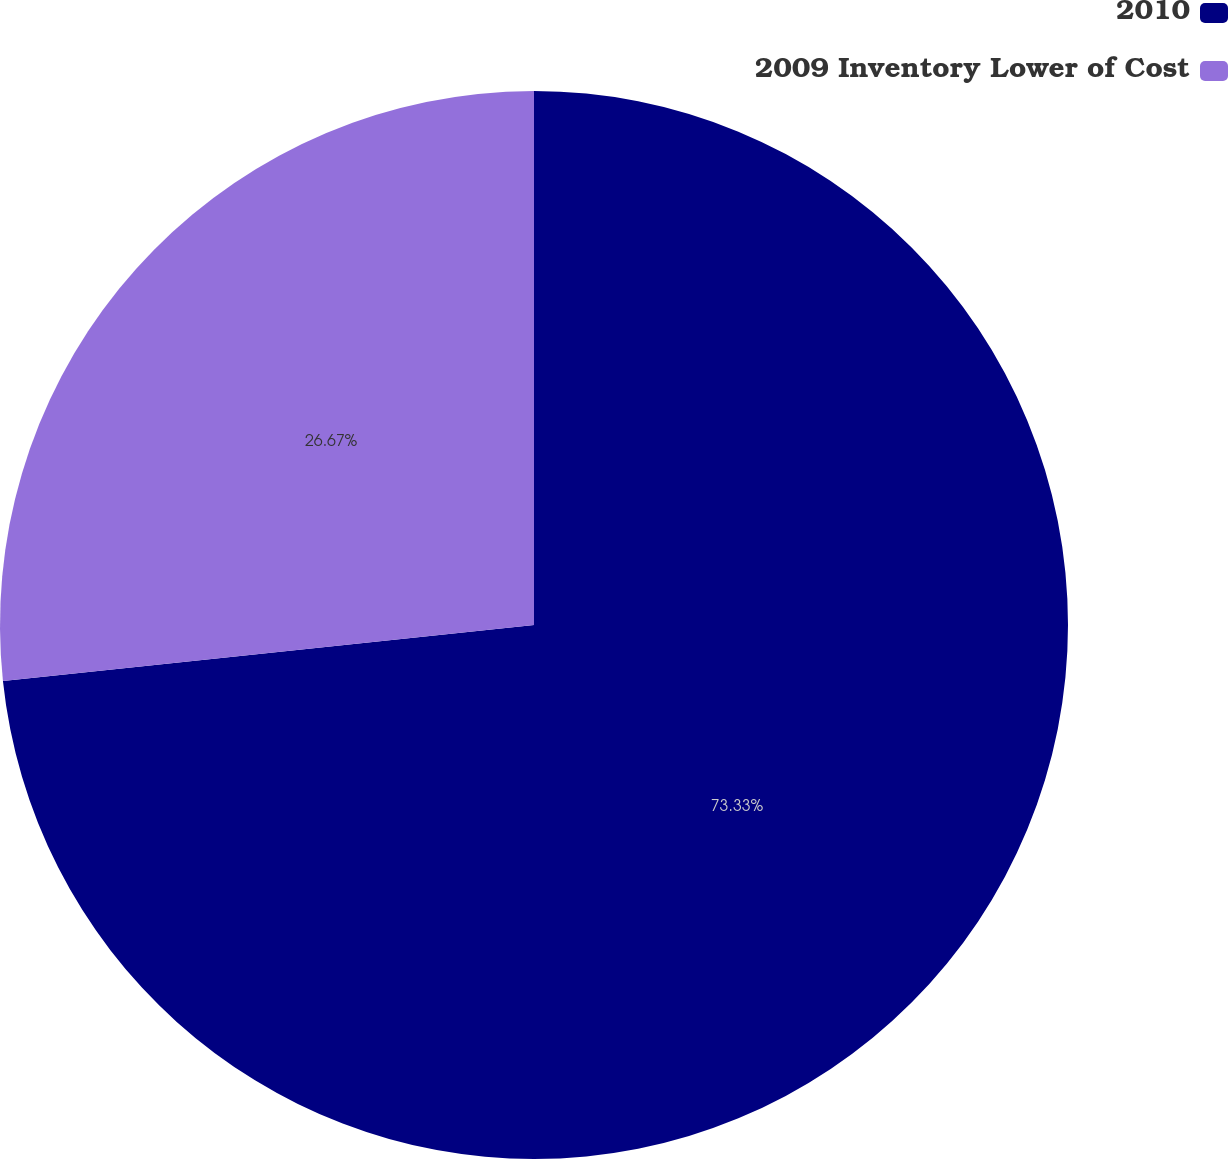Convert chart. <chart><loc_0><loc_0><loc_500><loc_500><pie_chart><fcel>2010<fcel>2009 Inventory Lower of Cost<nl><fcel>73.33%<fcel>26.67%<nl></chart> 